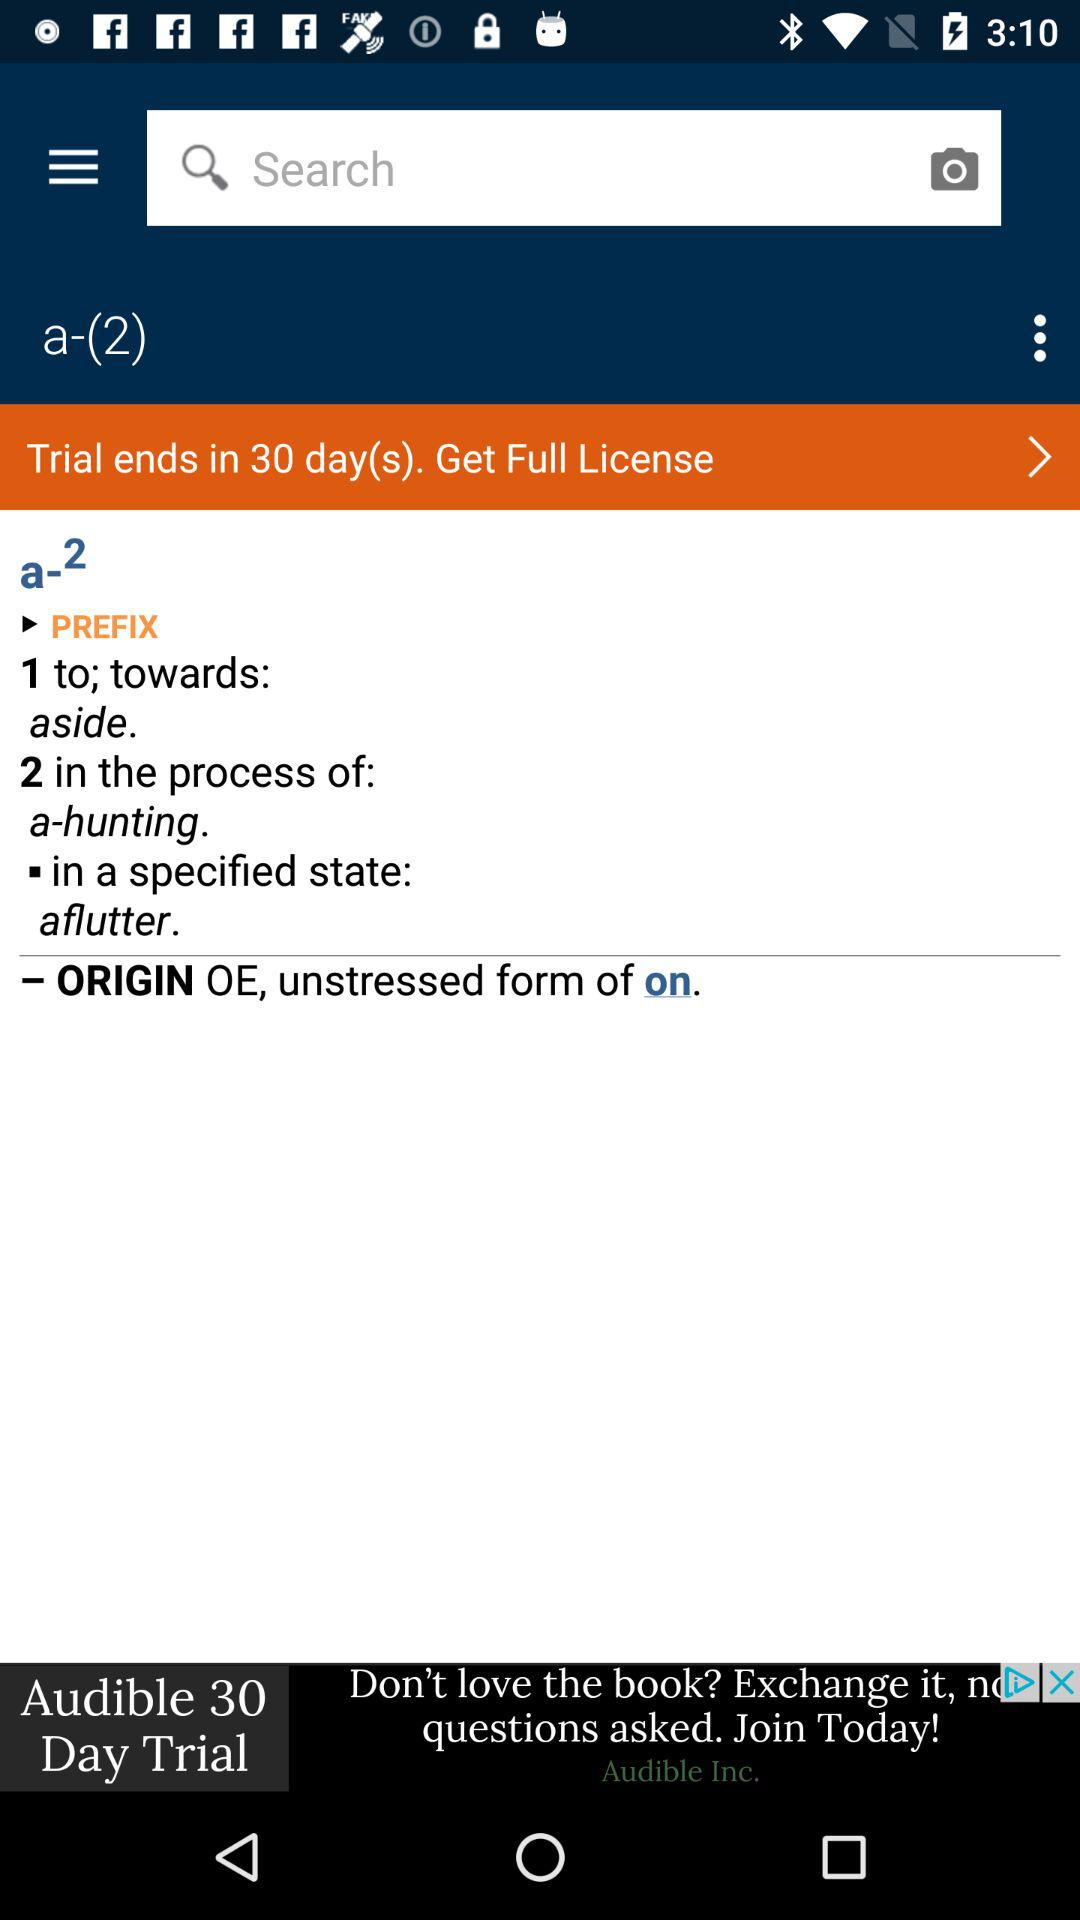In how many days does the trial end? The trial ends in 30 days. 